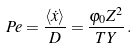<formula> <loc_0><loc_0><loc_500><loc_500>P e = \frac { \langle \dot { x } \rangle } { D } = \frac { \varphi _ { 0 } Z ^ { 2 } } { T Y } \, .</formula> 